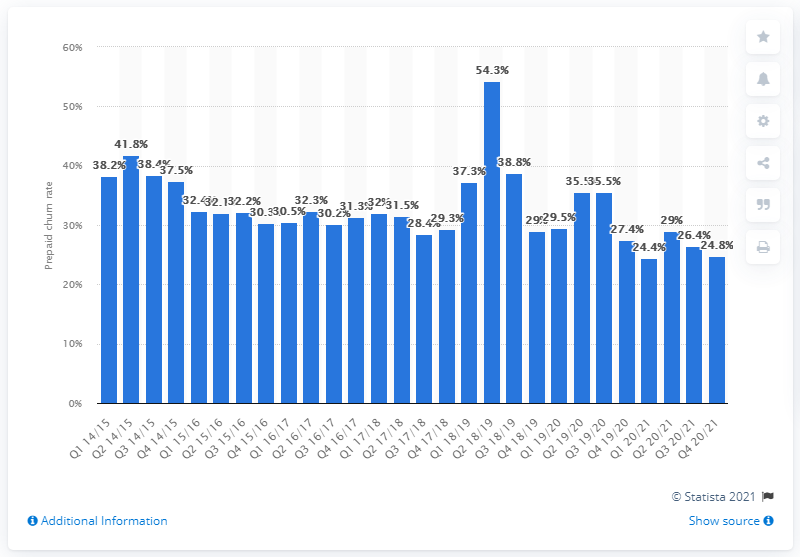Identify some key points in this picture. At the end of the fourth quarter of 2020/21, Vodafone's prepaid churn rate in Italy was 24.8%. 